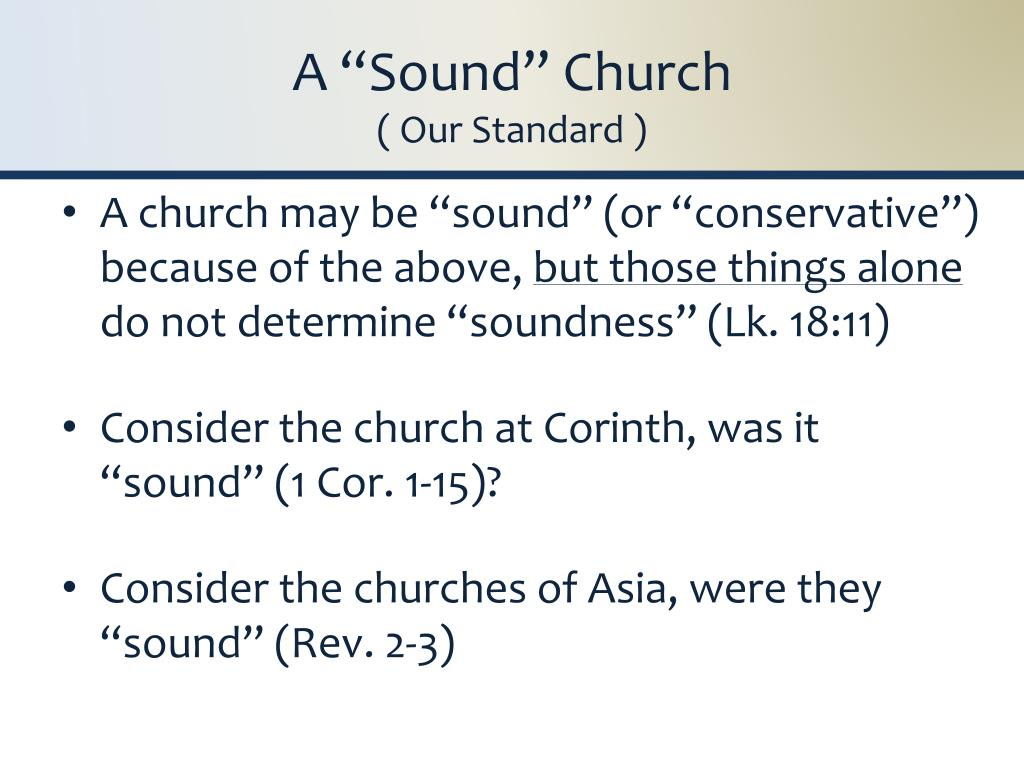Based on the information provided on the slide, what biblical criteria might the presenter be using to define the concept of a 'sound' church, and how do the provided scripture references contribute to this definition? The concept of a 'sound' church, as presented in the slide, likely emphasizes adherence to traditional doctrines or conservative values within the Christian context. The scriptures cited offer a foundational perspective: Luke 18:11 critiques self-righteousness, highlighting an attribute to avoid in a sound church. 1 Corinthians chapters 1-15 address various doctrines and corrections of church practices, likely reflecting structural and theological soundness. Revelation 2-3, involving letters to the churches of Asia, serves as a performance review by Jesus, indicating where these churches stand in terms of their faithfulness to Christian doctrines and practices. These references collectively guide a church towards maintaining or achieving soundness by aligning closely with biblical teachings and avoiding behaviors critiqued by these scriptures. 